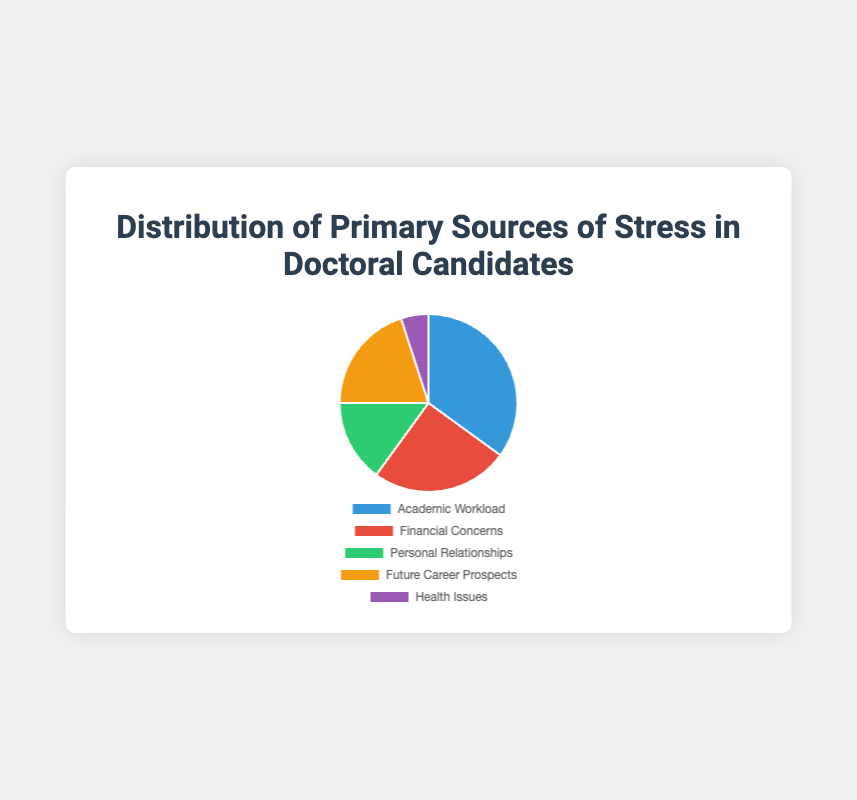What is the primary source of stress for doctoral candidates? The largest slice of the pie chart represents 'Academic Workload' at 35%. This indicates that the most significant source of stress is academic workload.
Answer: Academic Workload Which source of stress accounts for the least percentage? The smallest slice of the pie chart represents 'Health Issues' at 5%. This indicates that the least significant source of stress is health issues.
Answer: Health Issues What is the combined percentage of stress caused by financial concerns and future career prospects? The slice representing 'Financial Concerns' is 25% and the slice for 'Future Career Prospects' is 20%. Adding these percentages gives 25% + 20% = 45%.
Answer: 45% How does the percentage of stress from personal relationships compare to that from health issues? The slice for 'Personal Relationships' represents 15% and the slice for 'Health Issues' represents 5%. Comparatively, personal relationships account for a higher percentage of stress than health issues.
Answer: Personal relationships have a higher percentage Which color represents financial concerns? The color corresponding to 'Financial Concerns' in the pie chart is red. This can be identified by looking at the chart and legend, where each color is matched with a stress source.
Answer: Red What percentage of stress is not attributed to financial concerns or academic workload? 'Financial Concerns' account for 25% and 'Academic Workload' accounts for 35%. Adding these gives 60%. To find the remaining percentage, subtract this total from 100%. So, 100% - 60% = 40%.
Answer: 40% Which stress source is indicated by the green color? The green slice in the pie chart represents 'Personal Relationships'. This is determined by matching the green color in the legend to its corresponding label.
Answer: Personal Relationships Which stress sources together account for less than half of the total stress? The percentages for 'Personal Relationships', 'Future Career Prospects', and 'Health Issues' are 15%, 20%, and 5% respectively. Their combined total is 15% + 20% + 5% = 40%, which is less than half of 100%.
Answer: Personal Relationships, Future Career Prospects, Health Issues What is the visual relationship between the size of the slices for future career prospects and health issues? The slice for 'Future Career Prospects' is visually larger than the slice for 'Health Issues'. This can be seen because the 20% slice (Future Career Prospects) occupies more space compared to the 5% slice (Health Issues).
Answer: Future Career Prospects is larger 